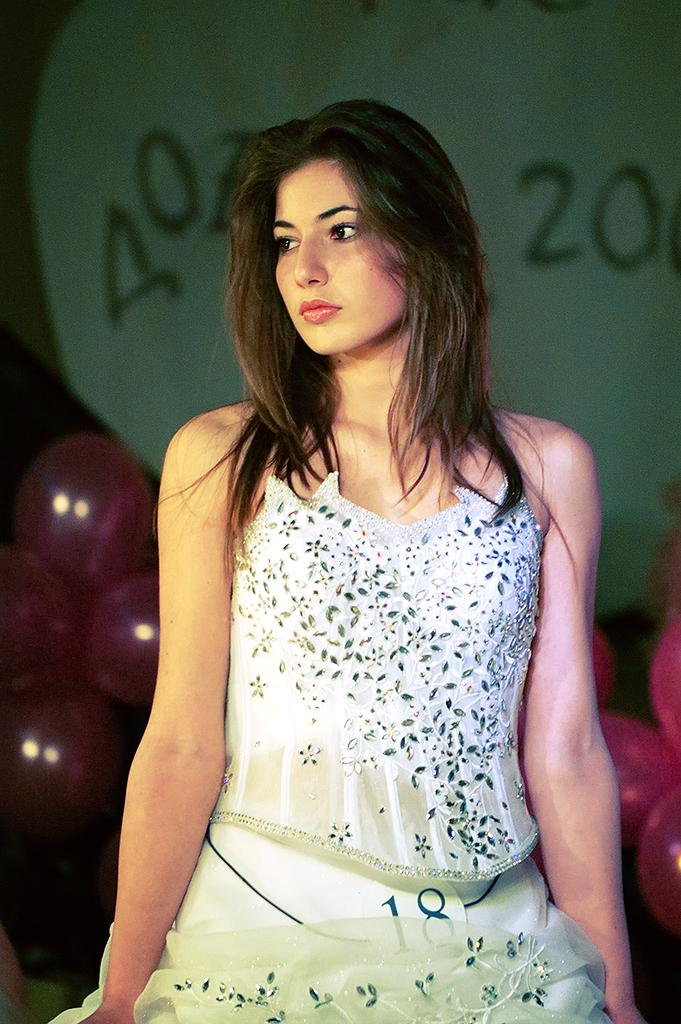Who or what is in the image? There is a person in the image. Can you describe the person's position? The person is in front. What can be seen behind the person? There are balloons behind the person. What is visible on the wall in the background of the image? There are numbers on the wall in the background of the image. What type of potato is being sold at the holiday market in the image? There is no potato, holiday, or market present in the image. 